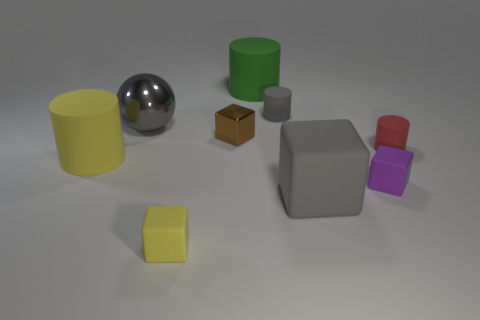There is a gray thing left of the brown metal block; what is its material?
Keep it short and to the point. Metal. Are there an equal number of large rubber objects behind the small red cylinder and large matte things?
Your answer should be very brief. No. Does the purple object have the same shape as the tiny brown thing?
Your answer should be very brief. Yes. Is there anything else of the same color as the large cube?
Give a very brief answer. Yes. The tiny rubber thing that is both left of the small red object and behind the large yellow cylinder has what shape?
Give a very brief answer. Cylinder. Is the number of big green objects that are behind the green thing the same as the number of gray rubber objects that are in front of the big yellow cylinder?
Offer a terse response. No. How many spheres are green things or large metallic things?
Give a very brief answer. 1. What number of small cubes have the same material as the yellow cylinder?
Offer a very short reply. 2. There is a small thing that is the same color as the large shiny ball; what shape is it?
Keep it short and to the point. Cylinder. What is the large object that is in front of the big green rubber thing and on the right side of the gray metallic ball made of?
Your answer should be very brief. Rubber. 